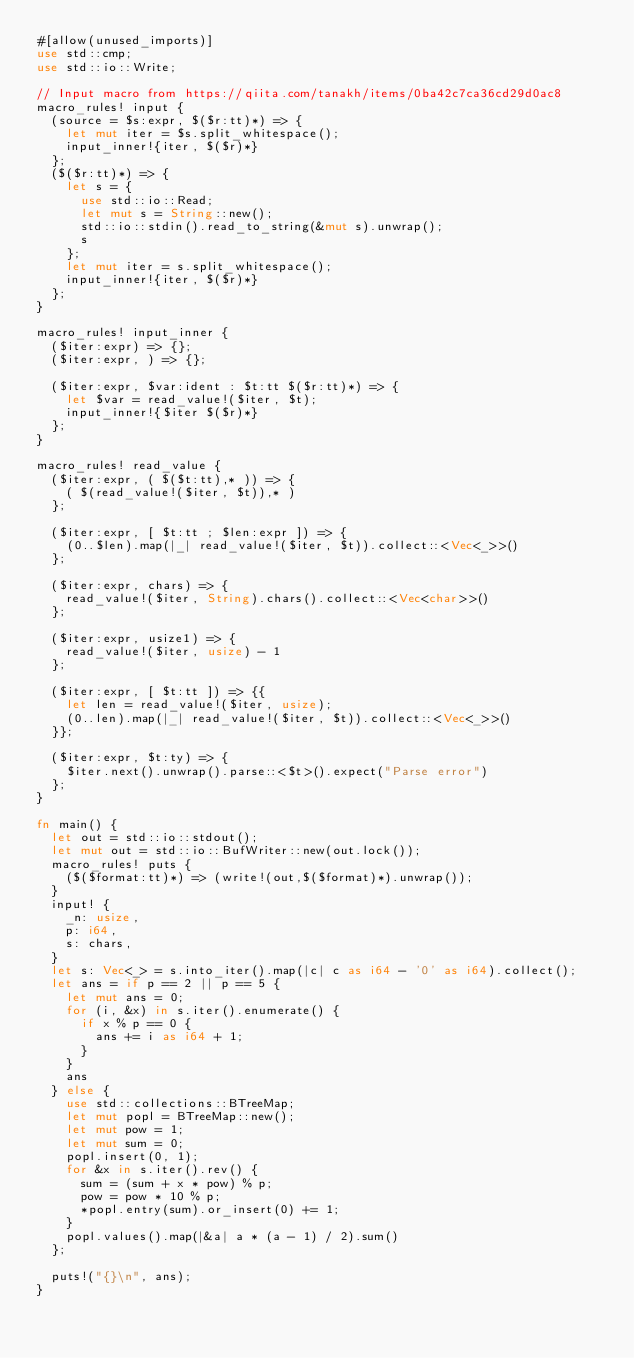<code> <loc_0><loc_0><loc_500><loc_500><_Rust_>#[allow(unused_imports)]
use std::cmp;
use std::io::Write;

// Input macro from https://qiita.com/tanakh/items/0ba42c7ca36cd29d0ac8
macro_rules! input {
  (source = $s:expr, $($r:tt)*) => {
    let mut iter = $s.split_whitespace();
    input_inner!{iter, $($r)*}
  };
  ($($r:tt)*) => {
    let s = {
      use std::io::Read;
      let mut s = String::new();
      std::io::stdin().read_to_string(&mut s).unwrap();
      s
    };
    let mut iter = s.split_whitespace();
    input_inner!{iter, $($r)*}
  };
}

macro_rules! input_inner {
  ($iter:expr) => {};
  ($iter:expr, ) => {};

  ($iter:expr, $var:ident : $t:tt $($r:tt)*) => {
    let $var = read_value!($iter, $t);
    input_inner!{$iter $($r)*}
  };
}

macro_rules! read_value {
  ($iter:expr, ( $($t:tt),* )) => {
    ( $(read_value!($iter, $t)),* )
  };

  ($iter:expr, [ $t:tt ; $len:expr ]) => {
    (0..$len).map(|_| read_value!($iter, $t)).collect::<Vec<_>>()
  };

  ($iter:expr, chars) => {
    read_value!($iter, String).chars().collect::<Vec<char>>()
  };

  ($iter:expr, usize1) => {
    read_value!($iter, usize) - 1
  };

  ($iter:expr, [ $t:tt ]) => {{
    let len = read_value!($iter, usize);
    (0..len).map(|_| read_value!($iter, $t)).collect::<Vec<_>>()
  }};

  ($iter:expr, $t:ty) => {
    $iter.next().unwrap().parse::<$t>().expect("Parse error")
  };
}

fn main() {
  let out = std::io::stdout();
  let mut out = std::io::BufWriter::new(out.lock());
  macro_rules! puts {
    ($($format:tt)*) => (write!(out,$($format)*).unwrap());
  }
  input! {
    _n: usize,
    p: i64,
    s: chars,
  }
  let s: Vec<_> = s.into_iter().map(|c| c as i64 - '0' as i64).collect();
  let ans = if p == 2 || p == 5 {
    let mut ans = 0;
    for (i, &x) in s.iter().enumerate() {
      if x % p == 0 {
        ans += i as i64 + 1;
      }
    }
    ans
  } else {
    use std::collections::BTreeMap;
    let mut popl = BTreeMap::new();
    let mut pow = 1;
    let mut sum = 0;
    popl.insert(0, 1);
    for &x in s.iter().rev() {
      sum = (sum + x * pow) % p;
      pow = pow * 10 % p;
      *popl.entry(sum).or_insert(0) += 1;
    }
    popl.values().map(|&a| a * (a - 1) / 2).sum()
  };

  puts!("{}\n", ans);
}
</code> 